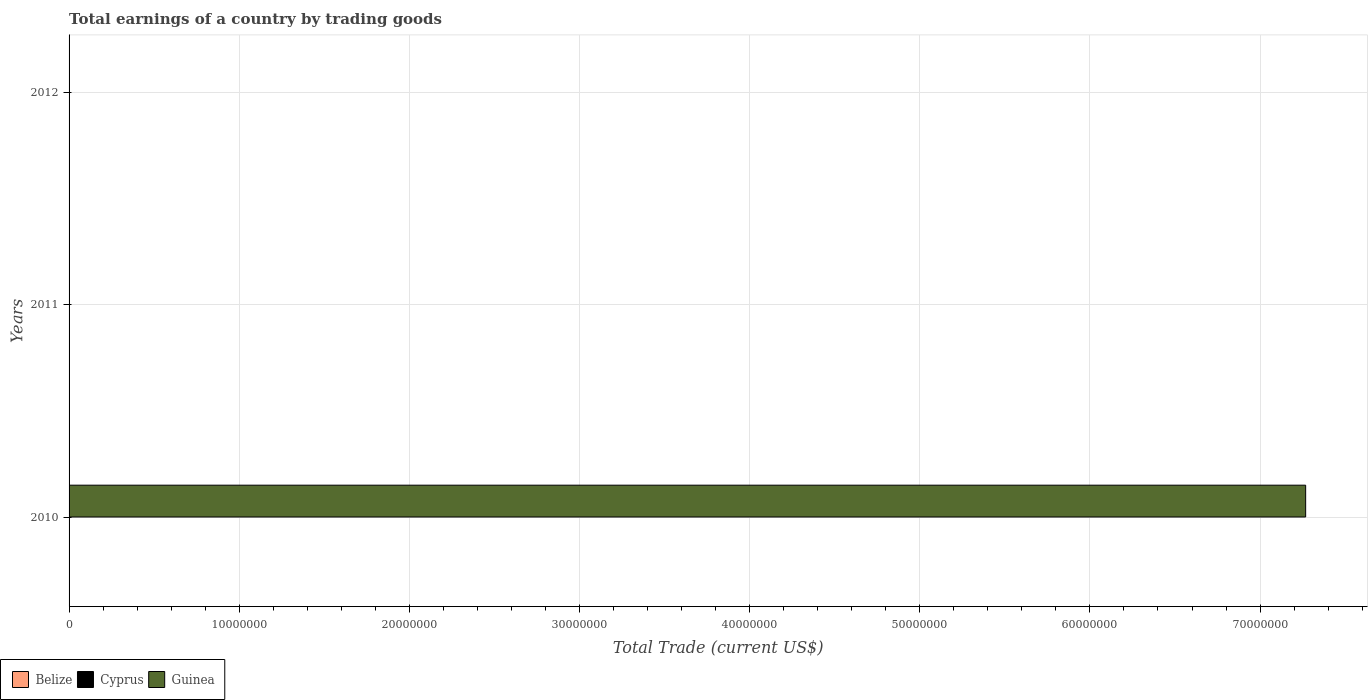Are the number of bars on each tick of the Y-axis equal?
Give a very brief answer. No. How many bars are there on the 2nd tick from the bottom?
Your response must be concise. 0. What is the label of the 2nd group of bars from the top?
Provide a succinct answer. 2011. In how many cases, is the number of bars for a given year not equal to the number of legend labels?
Ensure brevity in your answer.  3. What is the total earnings in Cyprus in 2010?
Provide a succinct answer. 0. Across all years, what is the maximum total earnings in Guinea?
Your answer should be compact. 7.27e+07. What is the difference between the total earnings in Cyprus in 2011 and the total earnings in Guinea in 2012?
Give a very brief answer. 0. What is the average total earnings in Cyprus per year?
Your answer should be very brief. 0. In how many years, is the total earnings in Guinea greater than 56000000 US$?
Your answer should be very brief. 1. What is the difference between the highest and the lowest total earnings in Guinea?
Provide a short and direct response. 7.27e+07. Is it the case that in every year, the sum of the total earnings in Belize and total earnings in Guinea is greater than the total earnings in Cyprus?
Offer a very short reply. No. How many years are there in the graph?
Your answer should be very brief. 3. Does the graph contain any zero values?
Ensure brevity in your answer.  Yes. Does the graph contain grids?
Provide a succinct answer. Yes. How are the legend labels stacked?
Provide a succinct answer. Horizontal. What is the title of the graph?
Your answer should be very brief. Total earnings of a country by trading goods. Does "Tonga" appear as one of the legend labels in the graph?
Offer a terse response. No. What is the label or title of the X-axis?
Your answer should be very brief. Total Trade (current US$). What is the Total Trade (current US$) in Guinea in 2010?
Your answer should be compact. 7.27e+07. What is the Total Trade (current US$) in Guinea in 2011?
Ensure brevity in your answer.  0. What is the Total Trade (current US$) of Belize in 2012?
Make the answer very short. 0. Across all years, what is the maximum Total Trade (current US$) in Guinea?
Offer a terse response. 7.27e+07. What is the total Total Trade (current US$) of Belize in the graph?
Provide a succinct answer. 0. What is the total Total Trade (current US$) in Guinea in the graph?
Offer a terse response. 7.27e+07. What is the average Total Trade (current US$) of Belize per year?
Offer a terse response. 0. What is the average Total Trade (current US$) of Cyprus per year?
Your response must be concise. 0. What is the average Total Trade (current US$) in Guinea per year?
Make the answer very short. 2.42e+07. What is the difference between the highest and the lowest Total Trade (current US$) of Guinea?
Ensure brevity in your answer.  7.27e+07. 